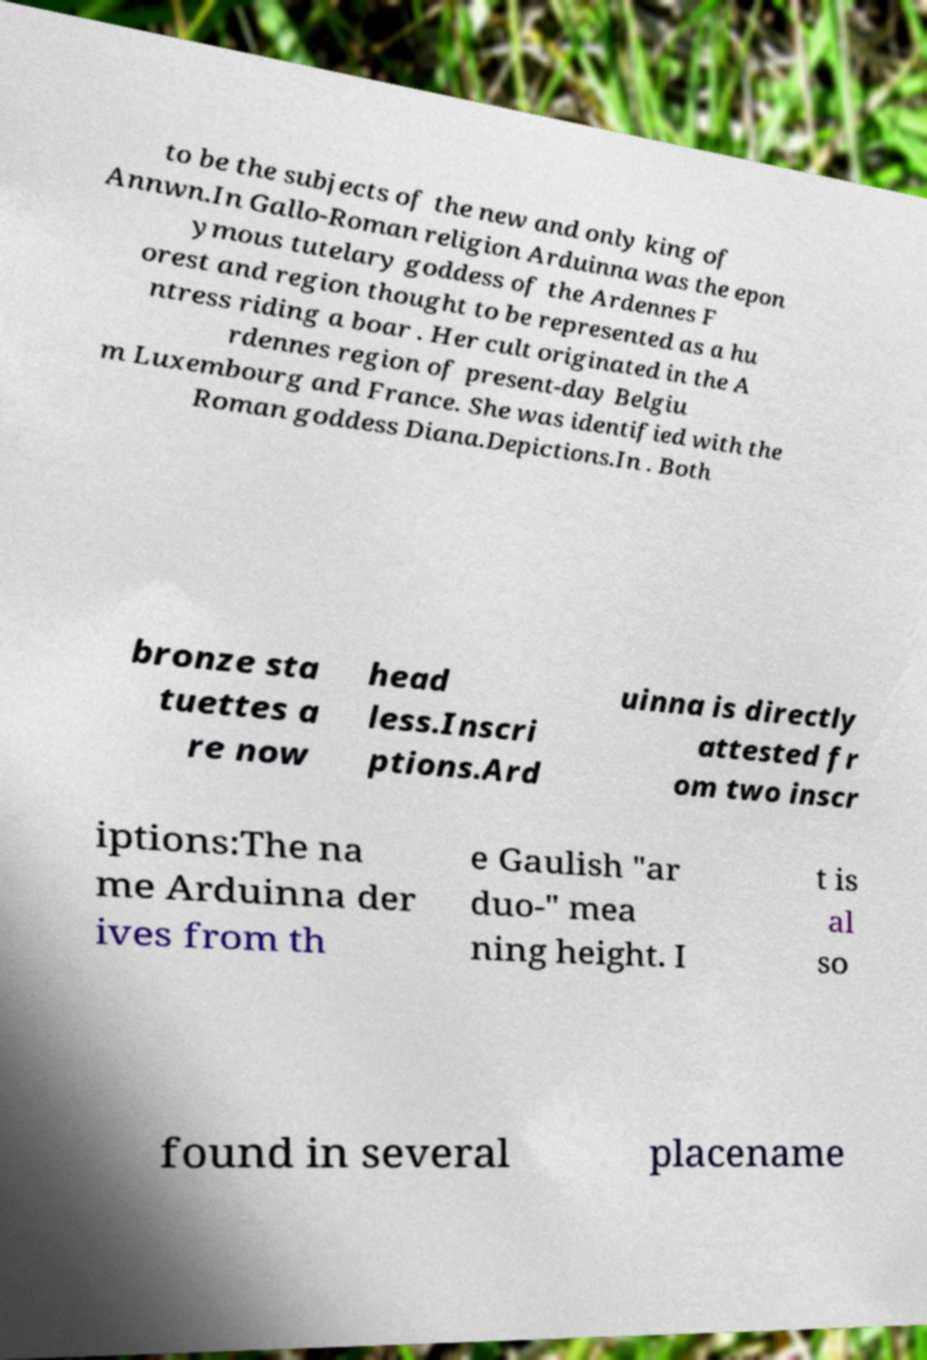I need the written content from this picture converted into text. Can you do that? to be the subjects of the new and only king of Annwn.In Gallo-Roman religion Arduinna was the epon ymous tutelary goddess of the Ardennes F orest and region thought to be represented as a hu ntress riding a boar . Her cult originated in the A rdennes region of present-day Belgiu m Luxembourg and France. She was identified with the Roman goddess Diana.Depictions.In . Both bronze sta tuettes a re now head less.Inscri ptions.Ard uinna is directly attested fr om two inscr iptions:The na me Arduinna der ives from th e Gaulish "ar duo-" mea ning height. I t is al so found in several placename 